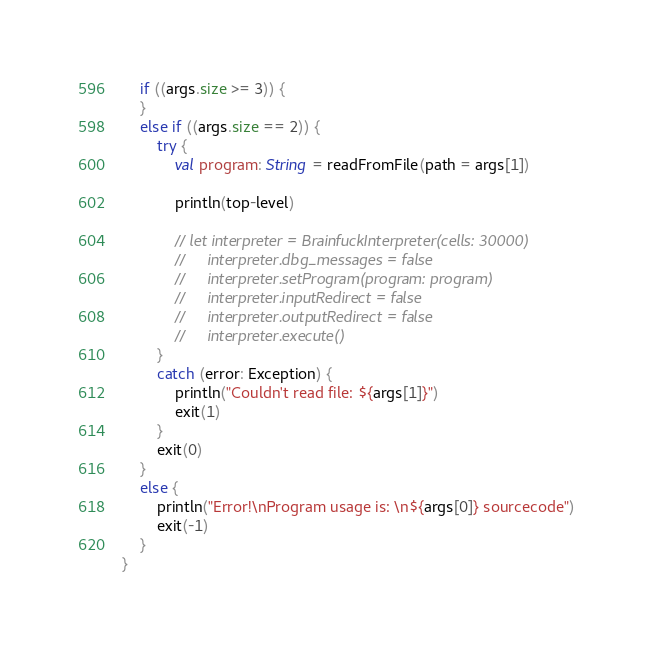<code> <loc_0><loc_0><loc_500><loc_500><_Kotlin_>
    if ((args.size >= 3)) {
    }
    else if ((args.size == 2)) {
        try {
            val program: String = readFromFile(path = args[1])

            println(top-level)

            // let interpreter = BrainfuckInterpreter(cells: 30000)
            //     interpreter.dbg_messages = false
            //     interpreter.setProgram(program: program)
            //     interpreter.inputRedirect = false
            //     interpreter.outputRedirect = false
            //     interpreter.execute()
        }
        catch (error: Exception) {
            println("Couldn't read file: ${args[1]}")
            exit(1)
        }
        exit(0)
    }
    else {
        println("Error!\nProgram usage is: \n${args[0]} sourcecode")
        exit(-1)
    }
}
</code> 